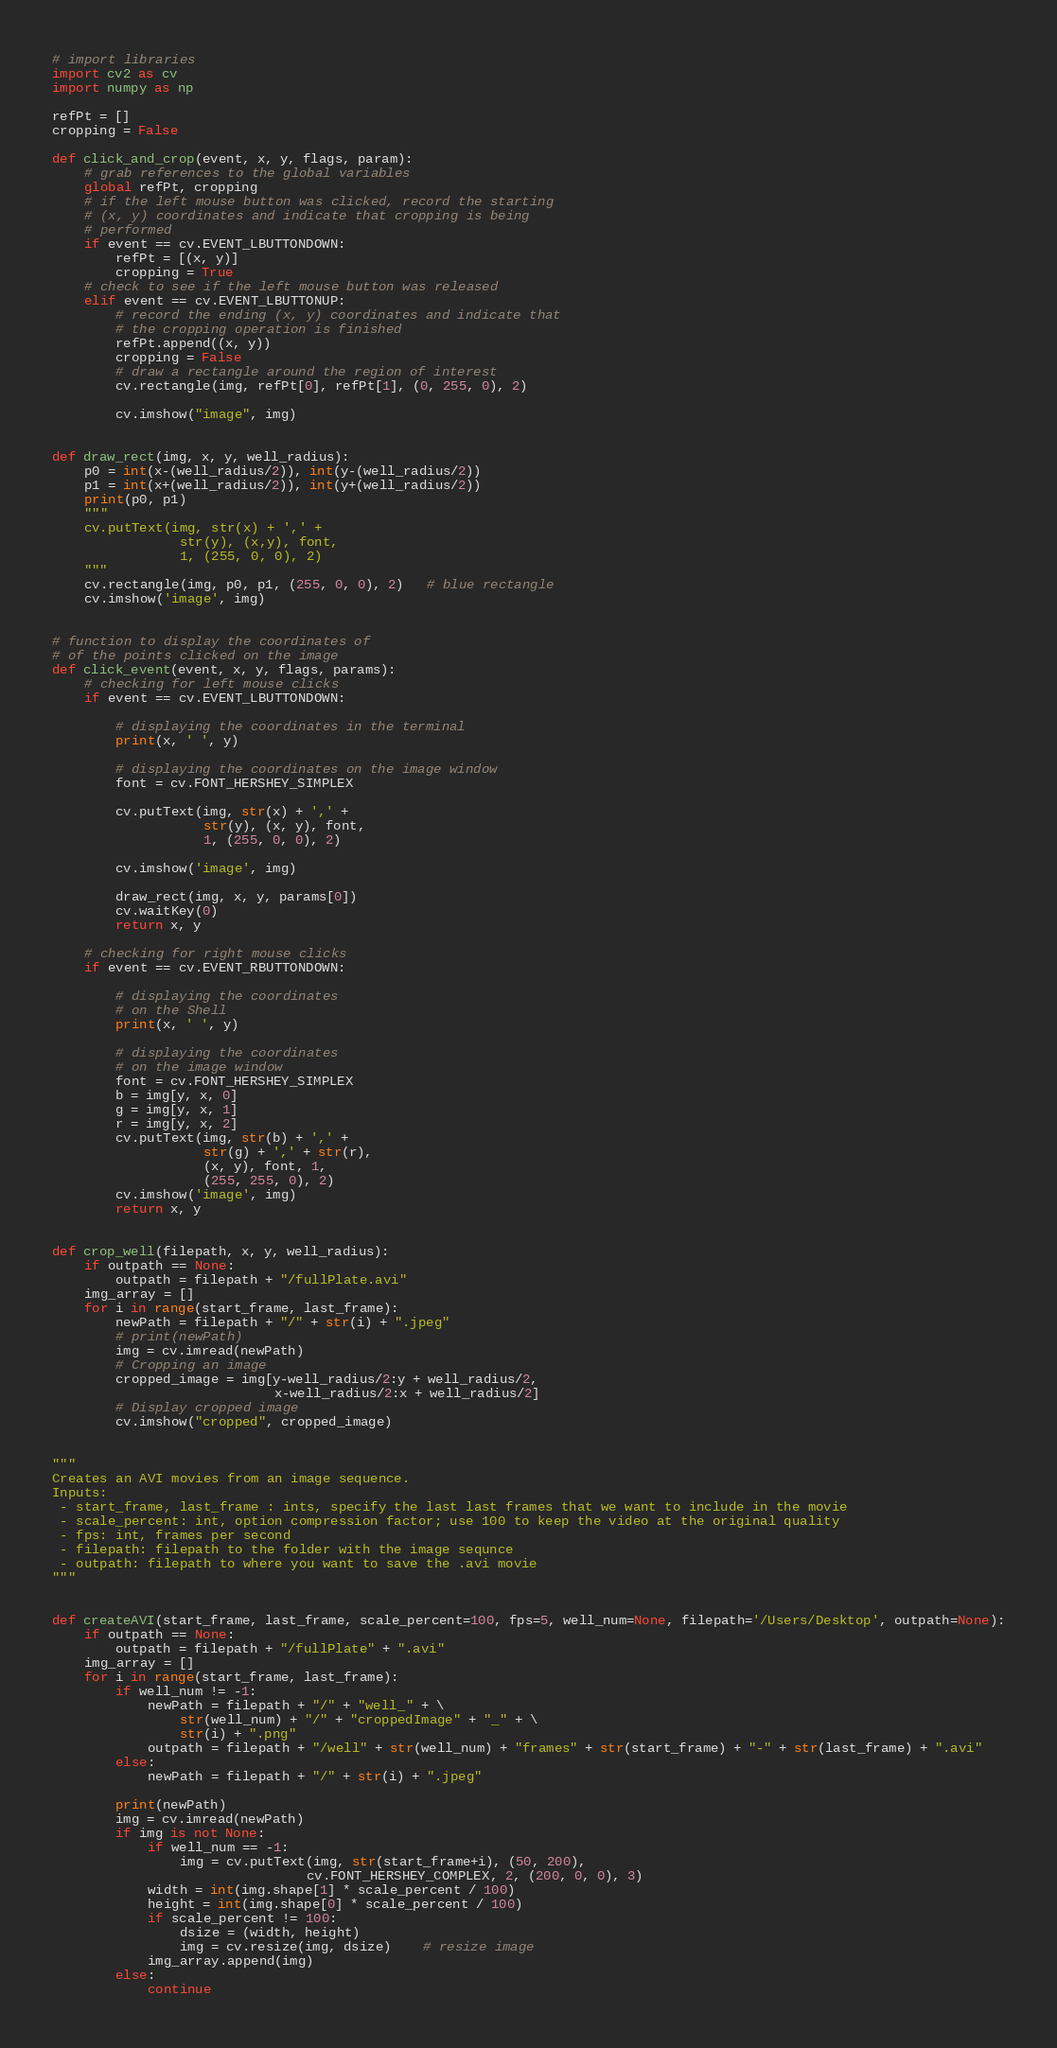Convert code to text. <code><loc_0><loc_0><loc_500><loc_500><_Python_># import libraries
import cv2 as cv
import numpy as np

refPt = []
cropping = False

def click_and_crop(event, x, y, flags, param):
    # grab references to the global variables
    global refPt, cropping
    # if the left mouse button was clicked, record the starting
    # (x, y) coordinates and indicate that cropping is being
    # performed
    if event == cv.EVENT_LBUTTONDOWN:
        refPt = [(x, y)]
        cropping = True
    # check to see if the left mouse button was released
    elif event == cv.EVENT_LBUTTONUP:
        # record the ending (x, y) coordinates and indicate that
        # the cropping operation is finished
        refPt.append((x, y))
        cropping = False
        # draw a rectangle around the region of interest
        cv.rectangle(img, refPt[0], refPt[1], (0, 255, 0), 2)

        cv.imshow("image", img)


def draw_rect(img, x, y, well_radius):
    p0 = int(x-(well_radius/2)), int(y-(well_radius/2))
    p1 = int(x+(well_radius/2)), int(y+(well_radius/2))
    print(p0, p1)
    """ 
    cv.putText(img, str(x) + ',' + 
                str(y), (x,y), font,
                1, (255, 0, 0), 2)
    """
    cv.rectangle(img, p0, p1, (255, 0, 0), 2)   # blue rectangle
    cv.imshow('image', img)


# function to display the coordinates of
# of the points clicked on the image
def click_event(event, x, y, flags, params):
    # checking for left mouse clicks
    if event == cv.EVENT_LBUTTONDOWN:

        # displaying the coordinates in the terminal
        print(x, ' ', y)

        # displaying the coordinates on the image window
        font = cv.FONT_HERSHEY_SIMPLEX

        cv.putText(img, str(x) + ',' +
                   str(y), (x, y), font,
                   1, (255, 0, 0), 2)

        cv.imshow('image', img)

        draw_rect(img, x, y, params[0])
        cv.waitKey(0)
        return x, y

    # checking for right mouse clicks
    if event == cv.EVENT_RBUTTONDOWN:

        # displaying the coordinates
        # on the Shell
        print(x, ' ', y)

        # displaying the coordinates
        # on the image window
        font = cv.FONT_HERSHEY_SIMPLEX
        b = img[y, x, 0]
        g = img[y, x, 1]
        r = img[y, x, 2]
        cv.putText(img, str(b) + ',' +
                   str(g) + ',' + str(r),
                   (x, y), font, 1,
                   (255, 255, 0), 2)
        cv.imshow('image', img)
        return x, y


def crop_well(filepath, x, y, well_radius):
    if outpath == None:
        outpath = filepath + "/fullPlate.avi"
    img_array = []
    for i in range(start_frame, last_frame):
        newPath = filepath + "/" + str(i) + ".jpeg"
        # print(newPath)
        img = cv.imread(newPath)
        # Cropping an image
        cropped_image = img[y-well_radius/2:y + well_radius/2,
                            x-well_radius/2:x + well_radius/2]
        # Display cropped image
        cv.imshow("cropped", cropped_image)


"""
Creates an AVI movies from an image sequence.
Inputs:
 - start_frame, last_frame : ints, specify the last last frames that we want to include in the movie
 - scale_percent: int, option compression factor; use 100 to keep the video at the original quality
 - fps: int, frames per second
 - filepath: filepath to the folder with the image sequnce
 - outpath: filepath to where you want to save the .avi movie
"""


def createAVI(start_frame, last_frame, scale_percent=100, fps=5, well_num=None, filepath='/Users/Desktop', outpath=None):
    if outpath == None:
        outpath = filepath + "/fullPlate" + ".avi"
    img_array = []
    for i in range(start_frame, last_frame):
        if well_num != -1:
            newPath = filepath + "/" + "well_" + \
                str(well_num) + "/" + "croppedImage" + "_" + \
                str(i) + ".png"
            outpath = filepath + "/well" + str(well_num) + "frames" + str(start_frame) + "-" + str(last_frame) + ".avi"
        else:
            newPath = filepath + "/" + str(i) + ".jpeg"

        print(newPath)
        img = cv.imread(newPath)
        if img is not None:
            if well_num == -1:
                img = cv.putText(img, str(start_frame+i), (50, 200),
                                cv.FONT_HERSHEY_COMPLEX, 2, (200, 0, 0), 3)
            width = int(img.shape[1] * scale_percent / 100)
            height = int(img.shape[0] * scale_percent / 100)
            if scale_percent != 100:
                dsize = (width, height)
                img = cv.resize(img, dsize)    # resize image
            img_array.append(img)
        else:
            continue</code> 